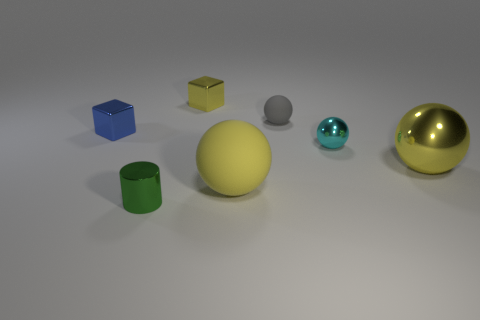Subtract 1 balls. How many balls are left? 3 Add 1 red blocks. How many objects exist? 8 Subtract all balls. How many objects are left? 3 Add 2 tiny shiny spheres. How many tiny shiny spheres are left? 3 Add 5 small yellow metallic things. How many small yellow metallic things exist? 6 Subtract 0 purple balls. How many objects are left? 7 Subtract all large green things. Subtract all balls. How many objects are left? 3 